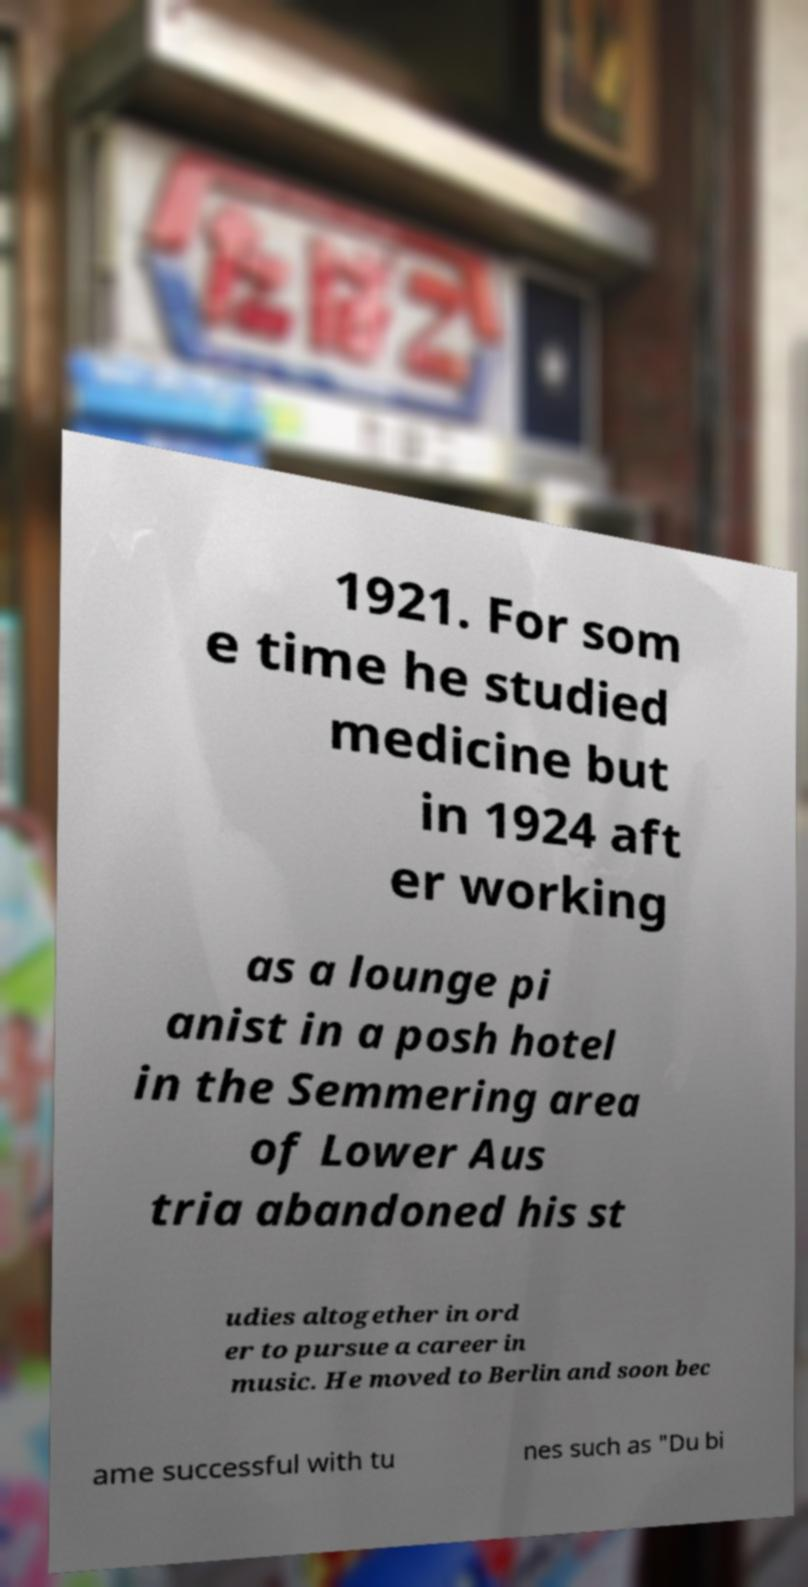What messages or text are displayed in this image? I need them in a readable, typed format. 1921. For som e time he studied medicine but in 1924 aft er working as a lounge pi anist in a posh hotel in the Semmering area of Lower Aus tria abandoned his st udies altogether in ord er to pursue a career in music. He moved to Berlin and soon bec ame successful with tu nes such as "Du bi 